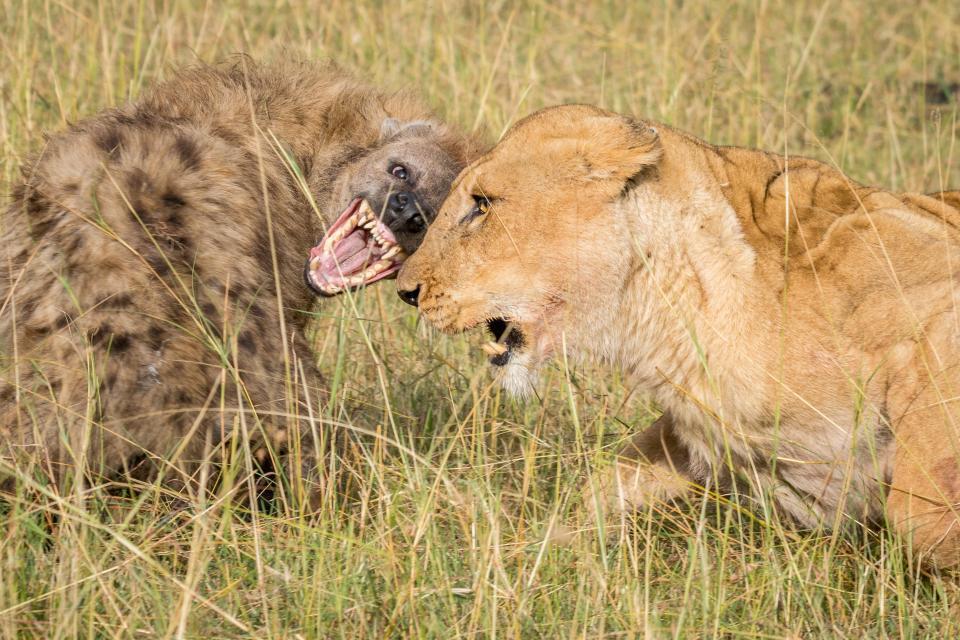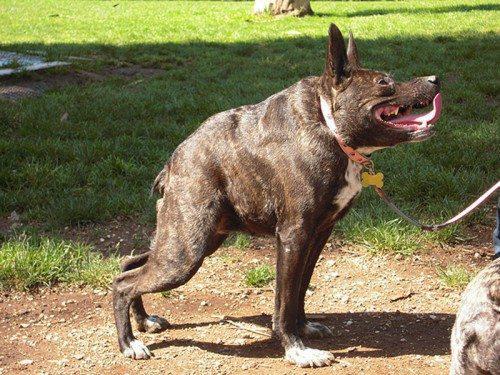The first image is the image on the left, the second image is the image on the right. Given the left and right images, does the statement "At least one hyena is facing right and showing teeth." hold true? Answer yes or no. Yes. The first image is the image on the left, the second image is the image on the right. Examine the images to the left and right. Is the description "An image shows an open-mouthed lion facing off with at least one hyena." accurate? Answer yes or no. Yes. 